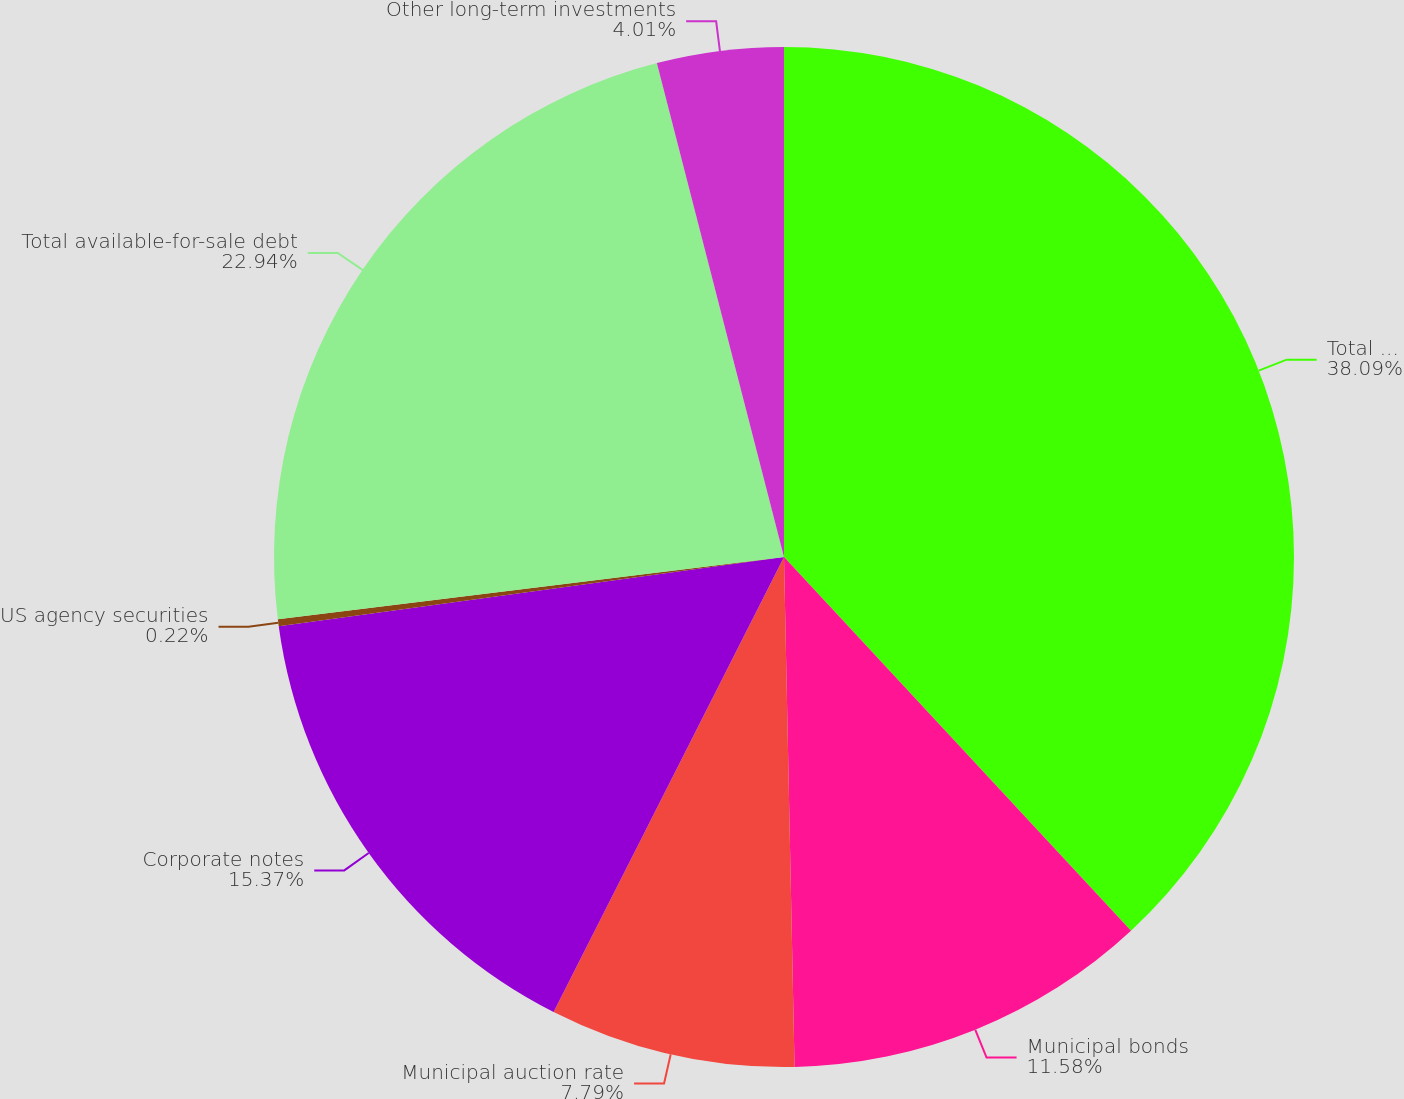Convert chart to OTSL. <chart><loc_0><loc_0><loc_500><loc_500><pie_chart><fcel>Total cash and cash<fcel>Municipal bonds<fcel>Municipal auction rate<fcel>Corporate notes<fcel>US agency securities<fcel>Total available-for-sale debt<fcel>Other long-term investments<nl><fcel>38.09%<fcel>11.58%<fcel>7.79%<fcel>15.37%<fcel>0.22%<fcel>22.94%<fcel>4.01%<nl></chart> 